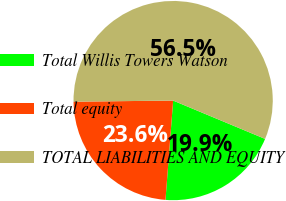Convert chart to OTSL. <chart><loc_0><loc_0><loc_500><loc_500><pie_chart><fcel>Total Willis Towers Watson<fcel>Total equity<fcel>TOTAL LIABILITIES AND EQUITY<nl><fcel>19.94%<fcel>23.6%<fcel>56.46%<nl></chart> 